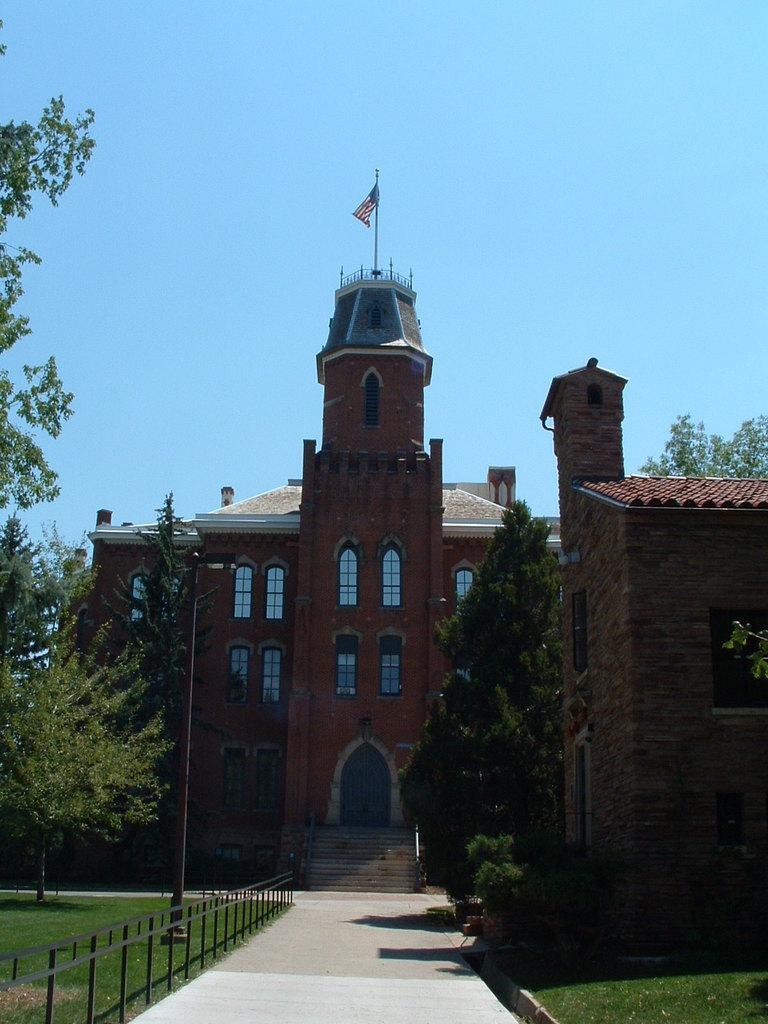Can you describe this image briefly? In this picture we can see some grass on the ground. There is some fencing on the left side. We can see a few trees and a building in the background. There is a flag and some windows are visible on this building. Sky is blue in color. 